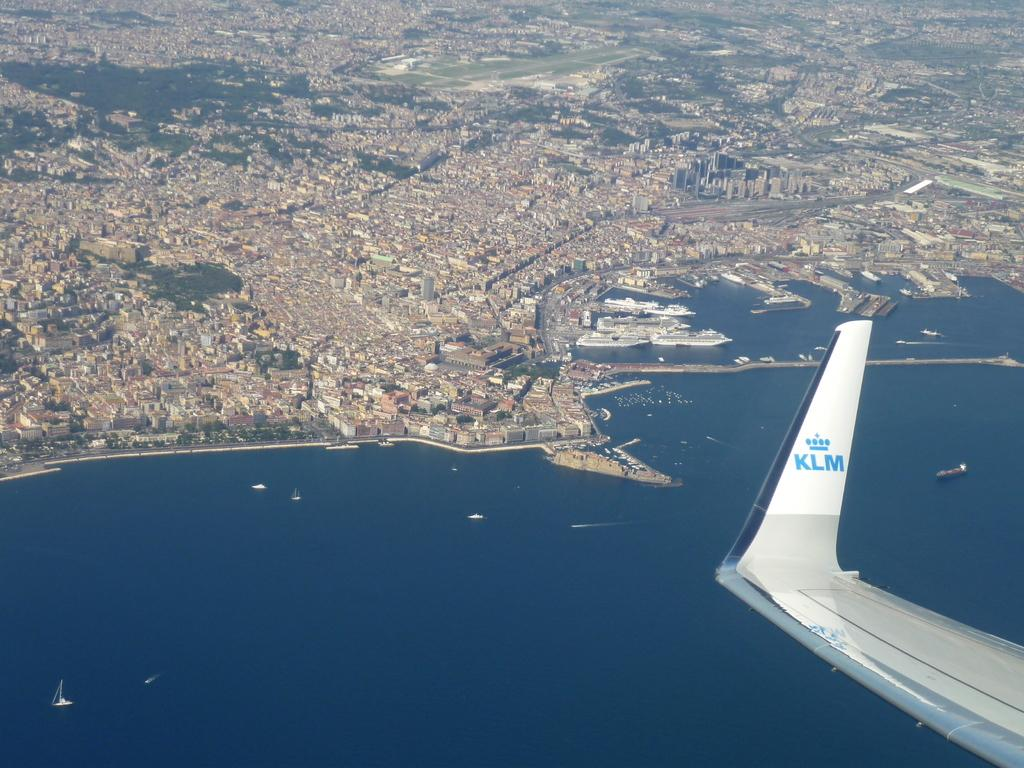<image>
Share a concise interpretation of the image provided. KLM airplane in the sky above a city. 